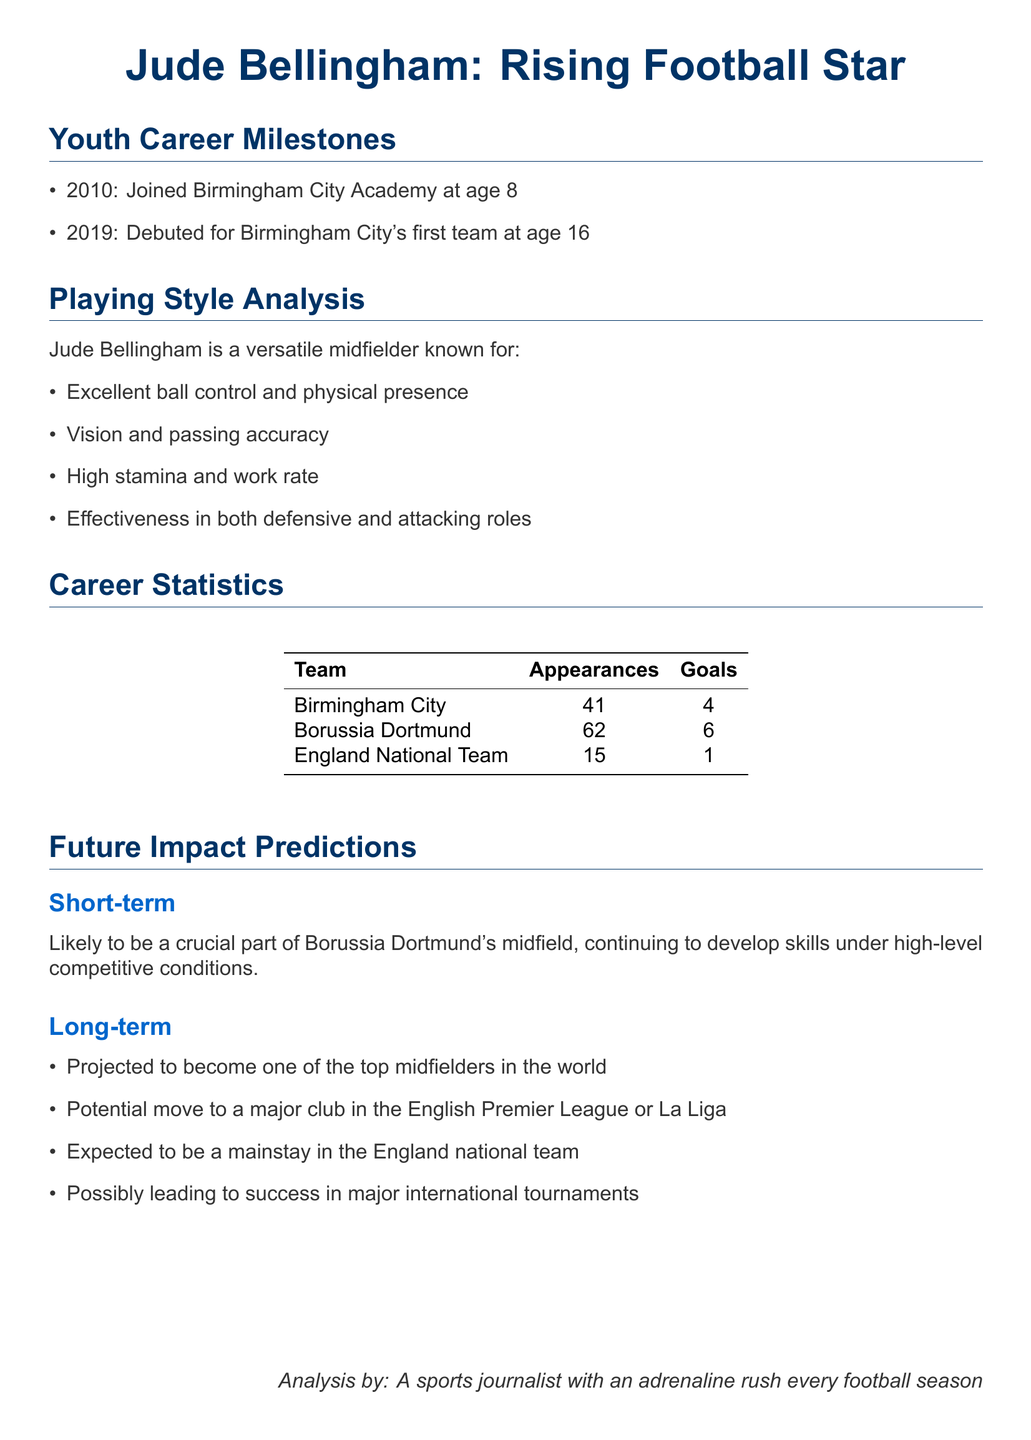What year did Jude Bellingham join Birmingham City Academy? The document states that he joined the academy in 2010 at age 8.
Answer: 2010 How old was Jude Bellingham when he debuted for Birmingham City's first team? The document indicates he debuted at age 16 in 2019.
Answer: 16 How many appearances did Bellingham have with Borussia Dortmund? The career statistics show he had 62 appearances with Borussia Dortmund.
Answer: 62 What position is Jude Bellingham known for? The document describes him as a versatile midfielder.
Answer: Midfielder What is a key characteristic of Bellingham's playing style? The document lists excellent ball control and physical presence as part of his playing style.
Answer: Excellent ball control What does the future impact prediction suggest for Bellingham's career? The document's long-term predictions indicate he is projected to become one of the top midfielders in the world.
Answer: One of the top midfielders in the world What is Bellingham’s goal count for the England national team? According to the table, he has scored 1 goal for the England national team.
Answer: 1 In what year did Jude Bellingham debut for the England national team? The document lists 15 appearances for the England national team but does not specify the debut year, requiring inference. He likely debuted shortly after his contributions to club level, after the 2019 season.
Answer: 2020 Which team did Bellingham play for prior to Borussia Dortmund? The document states he played for Birmingham City before joining Borussia Dortmund.
Answer: Birmingham City 